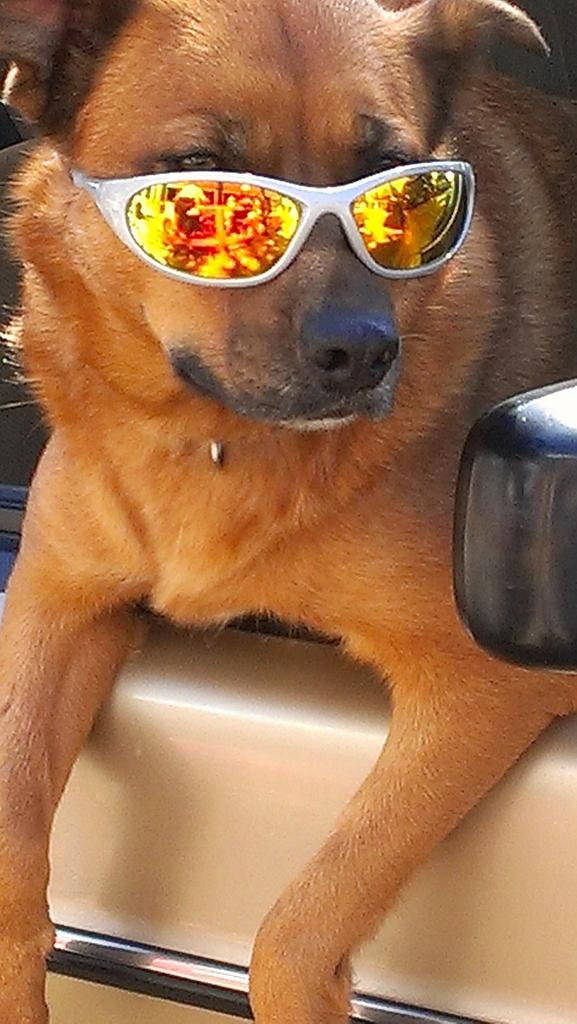What animal is present in the image? There is a dog in the image. What is the dog wearing? The dog is wearing a spectacle. What type of net can be seen in the image? There is no net present in the image; it features a dog wearing a spectacle. What kind of flower is being held by the dog in the image? There is no flower present in the image; it features a dog wearing a spectacle. 